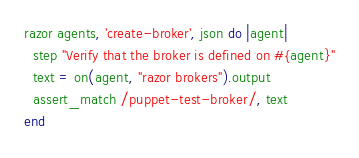<code> <loc_0><loc_0><loc_500><loc_500><_Ruby_>razor agents, 'create-broker', json do |agent|
  step "Verify that the broker is defined on #{agent}"
  text = on(agent, "razor brokers").output
  assert_match /puppet-test-broker/, text
end

</code> 